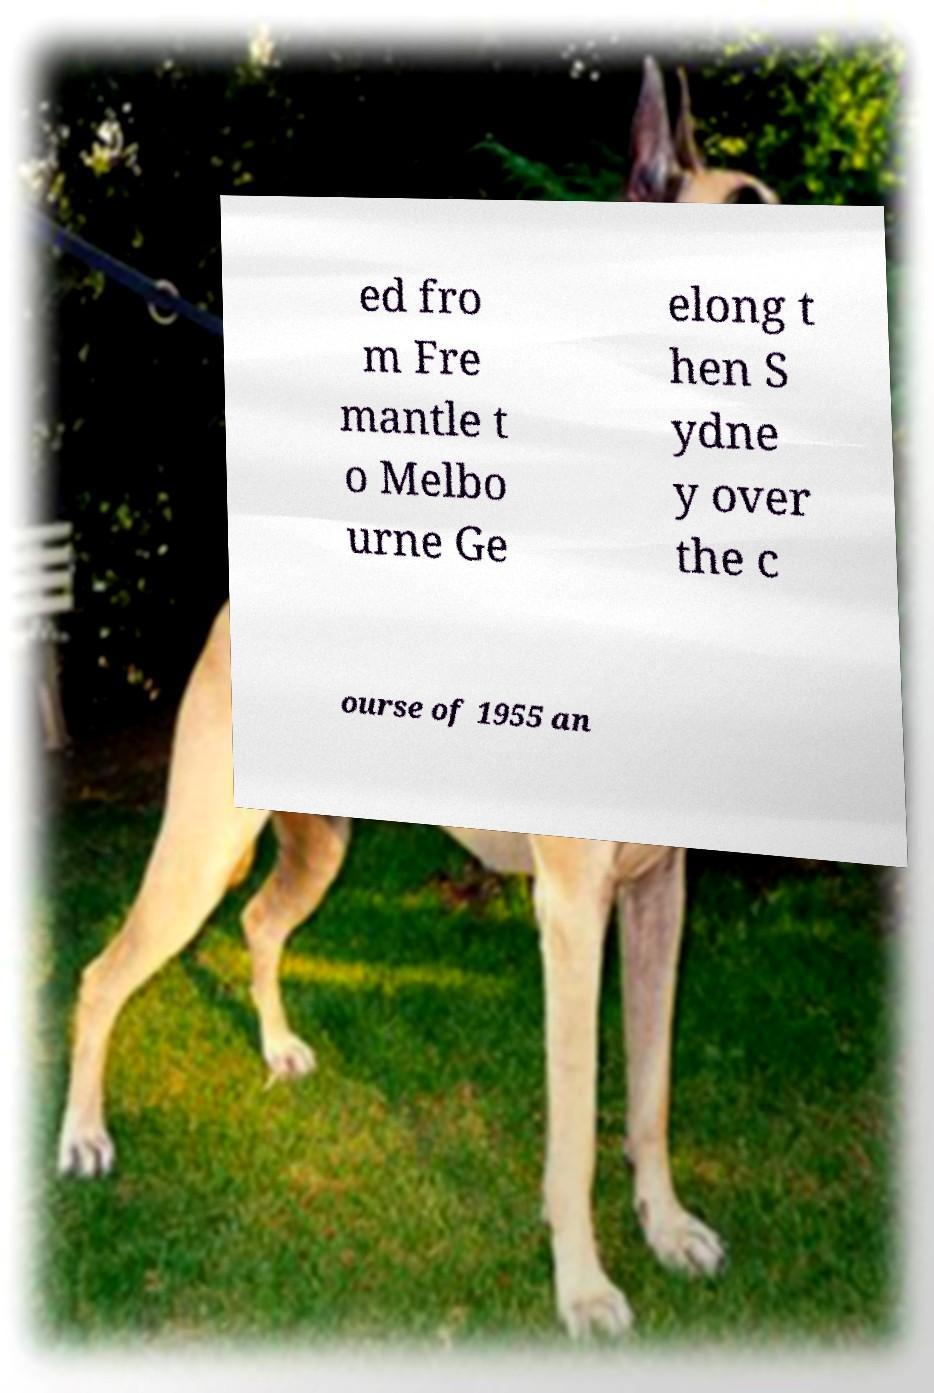Please identify and transcribe the text found in this image. ed fro m Fre mantle t o Melbo urne Ge elong t hen S ydne y over the c ourse of 1955 an 